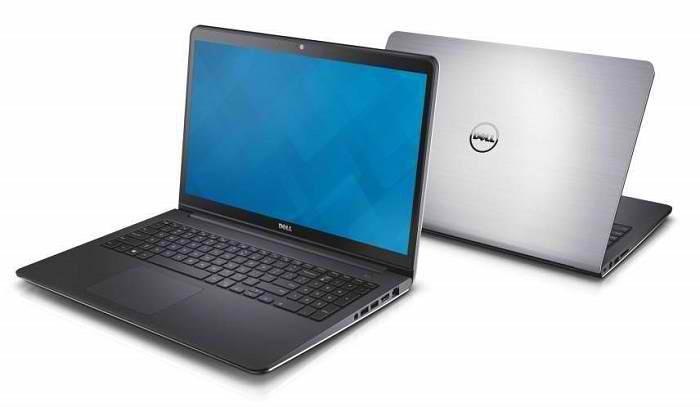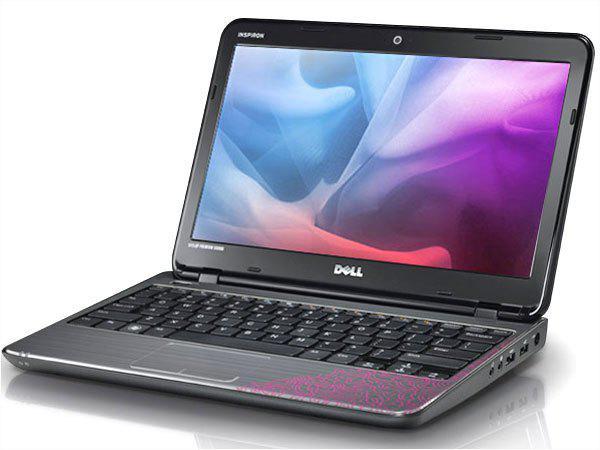The first image is the image on the left, the second image is the image on the right. For the images displayed, is the sentence "One image shows exactly two laptops with one laptop having a blue background on the screen and the other screen not visible, while the other image shows only one laptop with a colorful image on the screen." factually correct? Answer yes or no. Yes. 